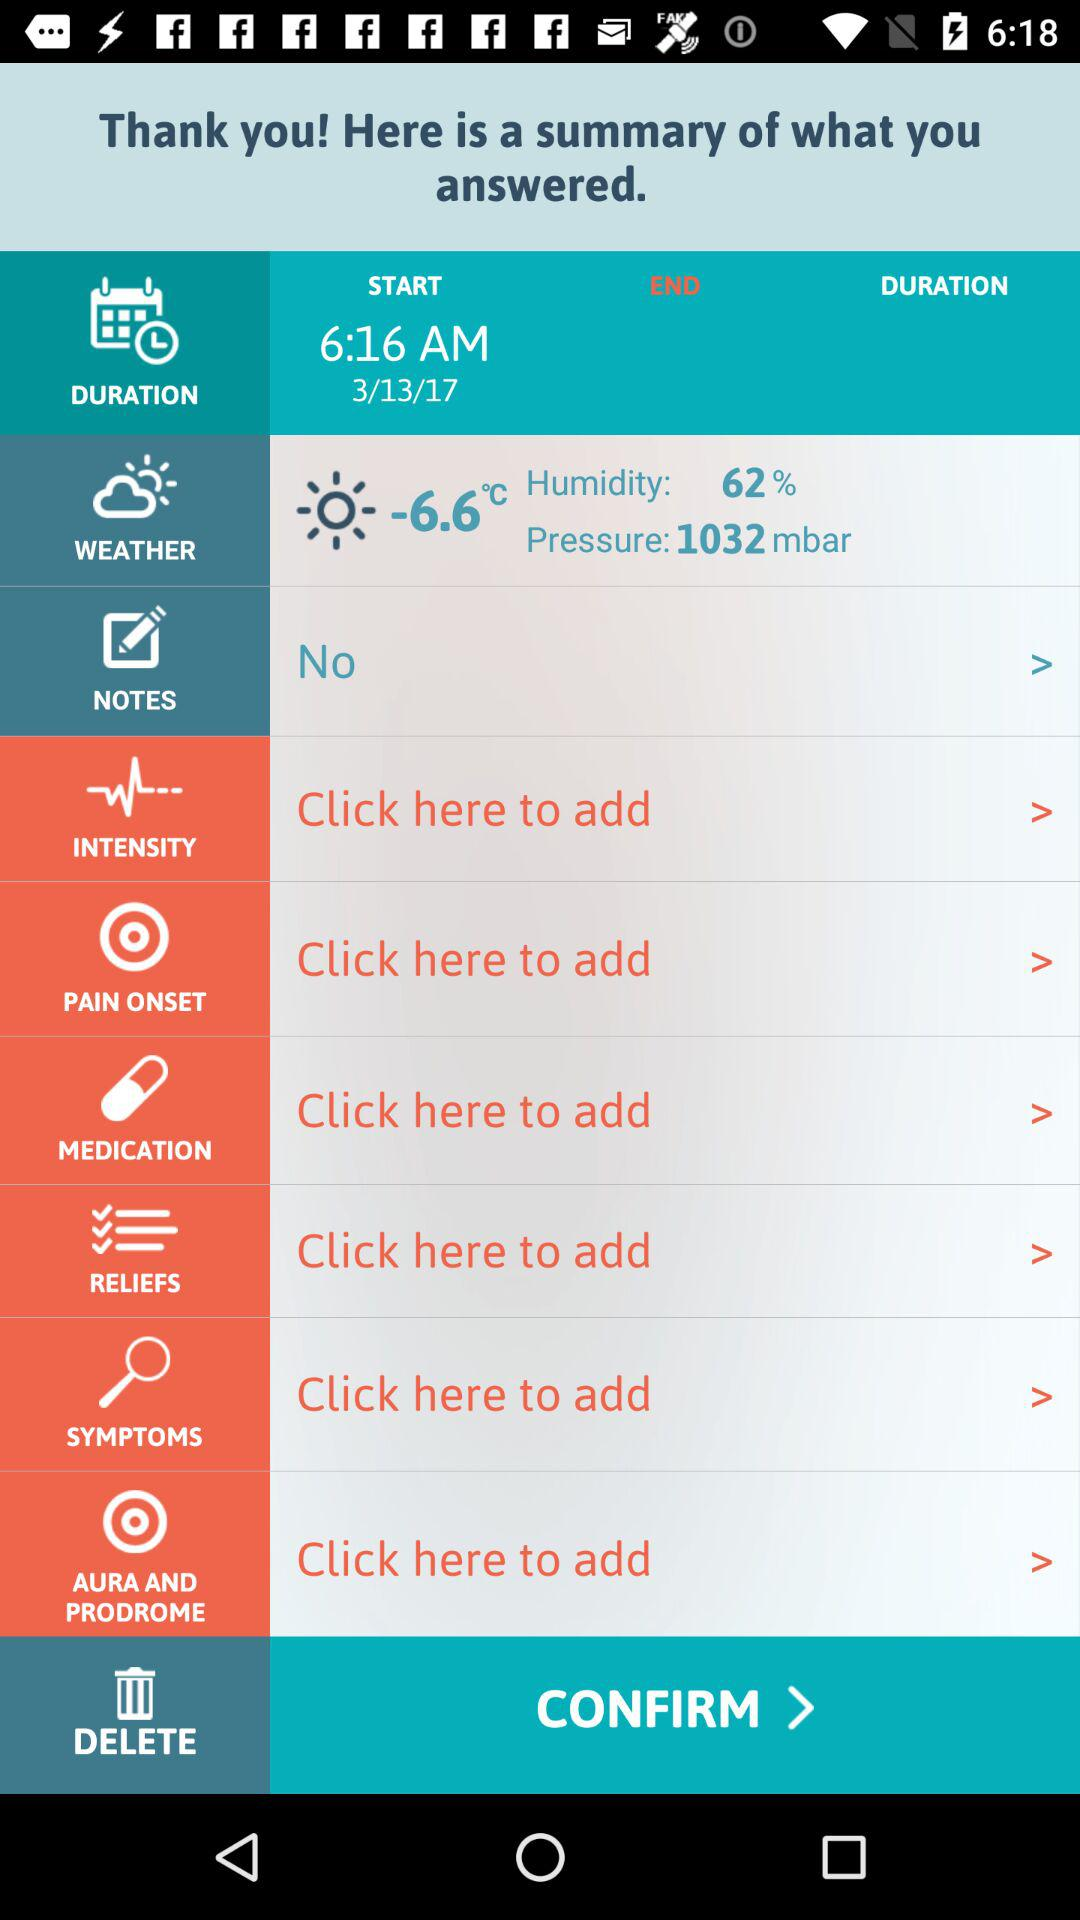What is the pressure in mbar? The pressure is 1032 mbar. 